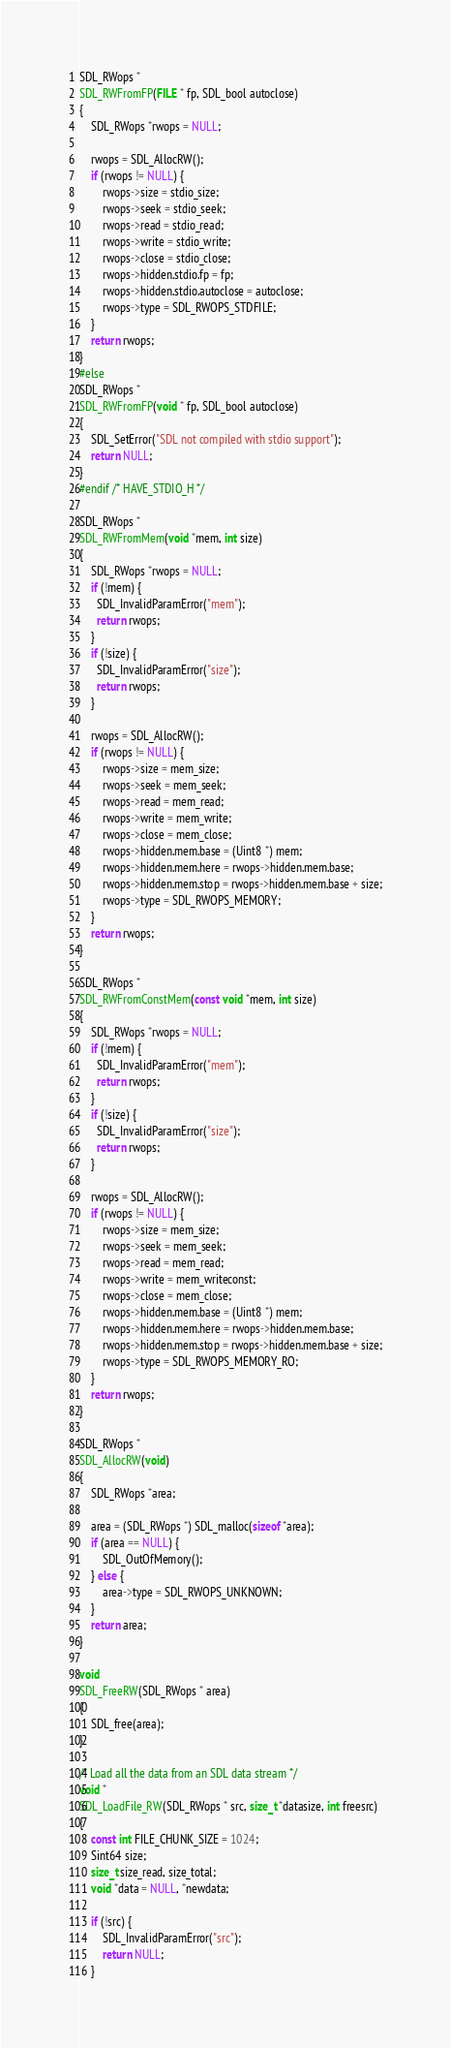<code> <loc_0><loc_0><loc_500><loc_500><_C_>SDL_RWops *
SDL_RWFromFP(FILE * fp, SDL_bool autoclose)
{
    SDL_RWops *rwops = NULL;

    rwops = SDL_AllocRW();
    if (rwops != NULL) {
        rwops->size = stdio_size;
        rwops->seek = stdio_seek;
        rwops->read = stdio_read;
        rwops->write = stdio_write;
        rwops->close = stdio_close;
        rwops->hidden.stdio.fp = fp;
        rwops->hidden.stdio.autoclose = autoclose;
        rwops->type = SDL_RWOPS_STDFILE;
    }
    return rwops;
}
#else
SDL_RWops *
SDL_RWFromFP(void * fp, SDL_bool autoclose)
{
    SDL_SetError("SDL not compiled with stdio support");
    return NULL;
}
#endif /* HAVE_STDIO_H */

SDL_RWops *
SDL_RWFromMem(void *mem, int size)
{
    SDL_RWops *rwops = NULL;
    if (!mem) {
      SDL_InvalidParamError("mem");
      return rwops;
    }
    if (!size) {
      SDL_InvalidParamError("size");
      return rwops;
    }

    rwops = SDL_AllocRW();
    if (rwops != NULL) {
        rwops->size = mem_size;
        rwops->seek = mem_seek;
        rwops->read = mem_read;
        rwops->write = mem_write;
        rwops->close = mem_close;
        rwops->hidden.mem.base = (Uint8 *) mem;
        rwops->hidden.mem.here = rwops->hidden.mem.base;
        rwops->hidden.mem.stop = rwops->hidden.mem.base + size;
        rwops->type = SDL_RWOPS_MEMORY;
    }
    return rwops;
}

SDL_RWops *
SDL_RWFromConstMem(const void *mem, int size)
{
    SDL_RWops *rwops = NULL;
    if (!mem) {
      SDL_InvalidParamError("mem");
      return rwops;
    }
    if (!size) {
      SDL_InvalidParamError("size");
      return rwops;
    }

    rwops = SDL_AllocRW();
    if (rwops != NULL) {
        rwops->size = mem_size;
        rwops->seek = mem_seek;
        rwops->read = mem_read;
        rwops->write = mem_writeconst;
        rwops->close = mem_close;
        rwops->hidden.mem.base = (Uint8 *) mem;
        rwops->hidden.mem.here = rwops->hidden.mem.base;
        rwops->hidden.mem.stop = rwops->hidden.mem.base + size;
        rwops->type = SDL_RWOPS_MEMORY_RO;
    }
    return rwops;
}

SDL_RWops *
SDL_AllocRW(void)
{
    SDL_RWops *area;

    area = (SDL_RWops *) SDL_malloc(sizeof *area);
    if (area == NULL) {
        SDL_OutOfMemory();
    } else {
        area->type = SDL_RWOPS_UNKNOWN;
    }
    return area;
}

void
SDL_FreeRW(SDL_RWops * area)
{
    SDL_free(area);
}

/* Load all the data from an SDL data stream */
void *
SDL_LoadFile_RW(SDL_RWops * src, size_t *datasize, int freesrc)
{
    const int FILE_CHUNK_SIZE = 1024;
    Sint64 size;
    size_t size_read, size_total;
    void *data = NULL, *newdata;

    if (!src) {
        SDL_InvalidParamError("src");
        return NULL;
    }
</code> 